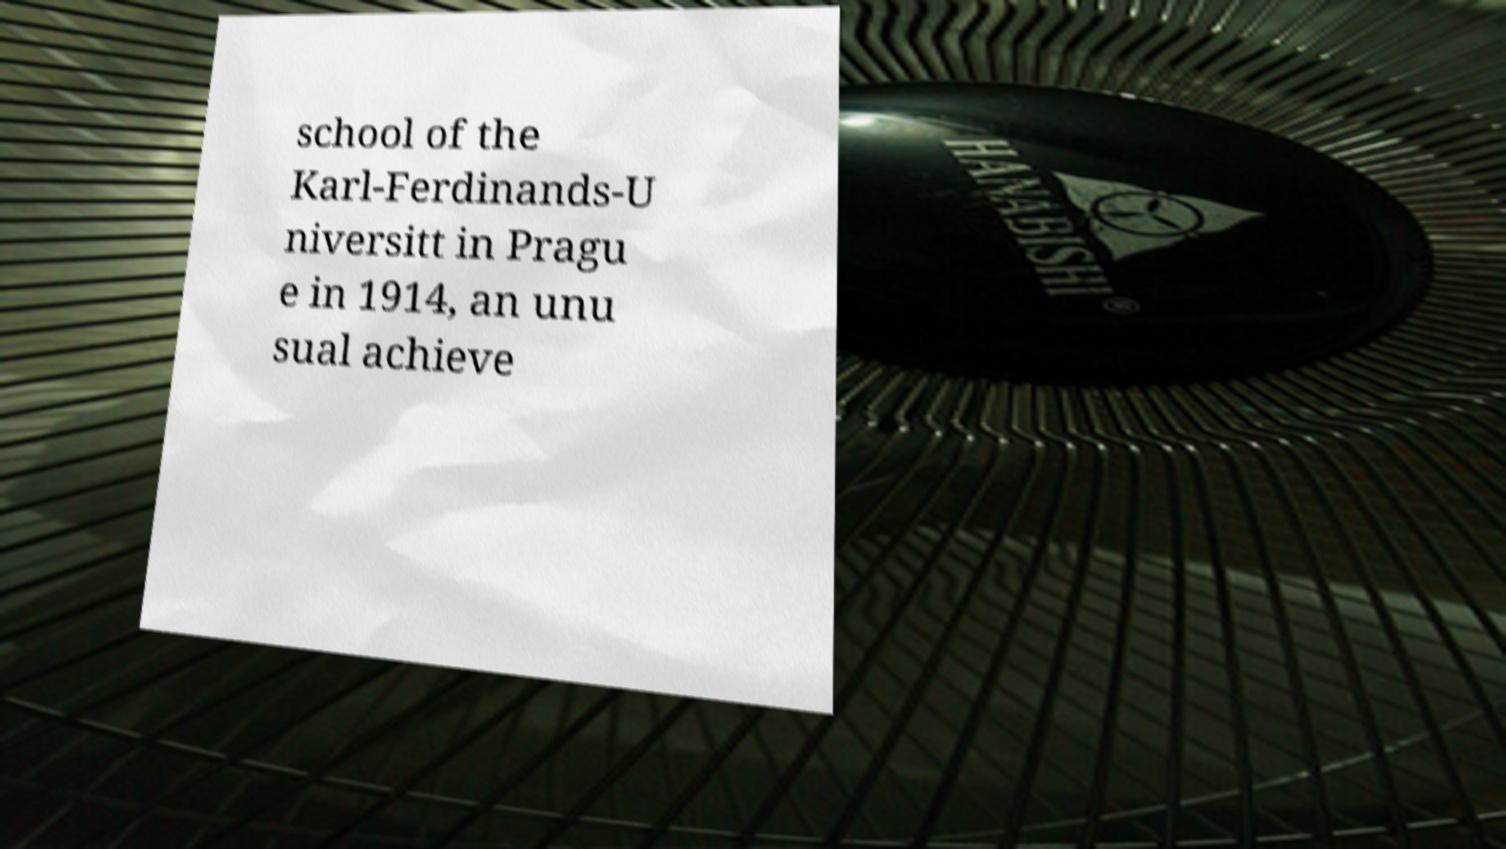Can you accurately transcribe the text from the provided image for me? school of the Karl-Ferdinands-U niversitt in Pragu e in 1914, an unu sual achieve 